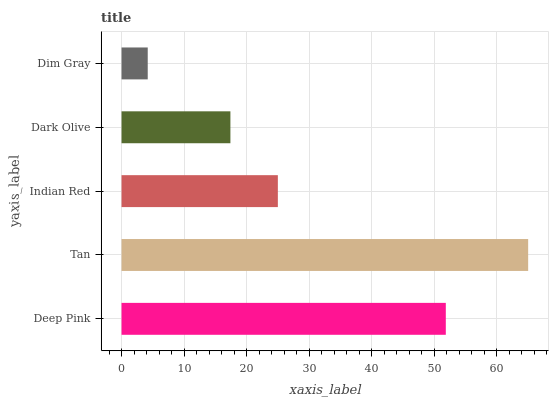Is Dim Gray the minimum?
Answer yes or no. Yes. Is Tan the maximum?
Answer yes or no. Yes. Is Indian Red the minimum?
Answer yes or no. No. Is Indian Red the maximum?
Answer yes or no. No. Is Tan greater than Indian Red?
Answer yes or no. Yes. Is Indian Red less than Tan?
Answer yes or no. Yes. Is Indian Red greater than Tan?
Answer yes or no. No. Is Tan less than Indian Red?
Answer yes or no. No. Is Indian Red the high median?
Answer yes or no. Yes. Is Indian Red the low median?
Answer yes or no. Yes. Is Deep Pink the high median?
Answer yes or no. No. Is Tan the low median?
Answer yes or no. No. 